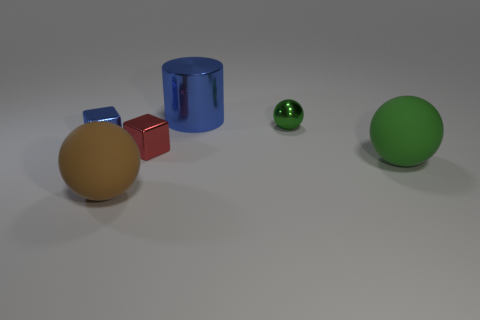Subtract all tiny green metal spheres. How many spheres are left? 2 Subtract all green balls. How many were subtracted if there are1green balls left? 1 Subtract 1 cylinders. How many cylinders are left? 0 Subtract all purple balls. Subtract all yellow cylinders. How many balls are left? 3 Subtract all purple cubes. How many red spheres are left? 0 Subtract all big cyan matte things. Subtract all tiny objects. How many objects are left? 3 Add 4 red objects. How many red objects are left? 5 Add 4 green matte balls. How many green matte balls exist? 5 Add 3 green metallic balls. How many objects exist? 9 Subtract all brown balls. How many balls are left? 2 